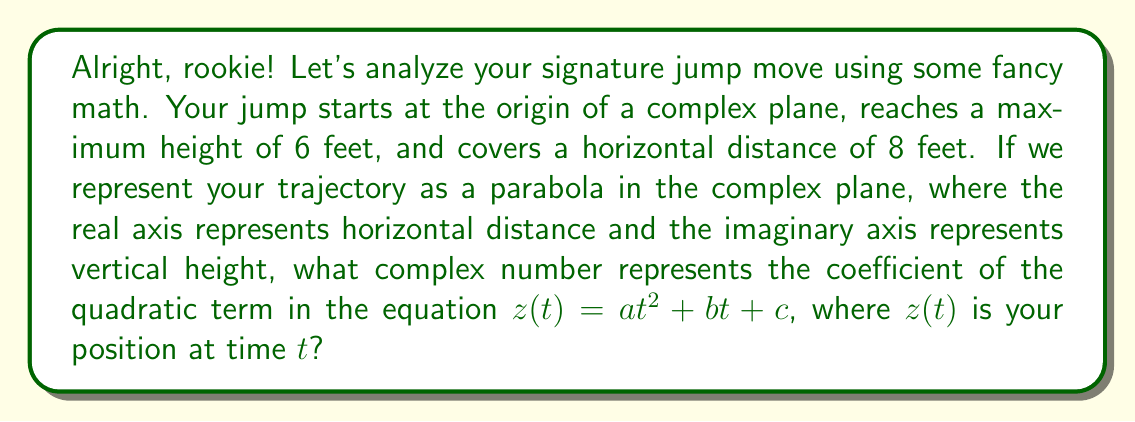Help me with this question. Let's break this down step by step, champ:

1) In the complex plane, the trajectory can be represented as:
   $z(t) = x(t) + iy(t)$, where $x(t)$ is the horizontal position and $y(t)$ is the vertical position.

2) We know that $x(t)$ ranges from 0 to 8, and $y(t)$ ranges from 0 to 6 and back to 0.

3) Let's assume the jump takes 1 unit of time. Then:
   $x(t) = 8t$ (linear motion)
   $y(t) = -24t^2 + 24t$ (parabolic motion reaching max height at $t=0.5$)

4) Combining these:
   $z(t) = (8t) + i(-24t^2 + 24t)$
   $z(t) = 8t + (-24i)t^2 + 24it$

5) Rearranging to match the standard form $z(t) = at^2 + bt + c$:
   $z(t) = (-24i)t^2 + (8 + 24i)t + 0$

6) Therefore, $a = -24i$

The coefficient $a$ represents the curvature of the parabola in the complex plane. The negative imaginary part indicates that the parabola opens downward in the imaginary (vertical) direction.
Answer: $a = -24i$ 